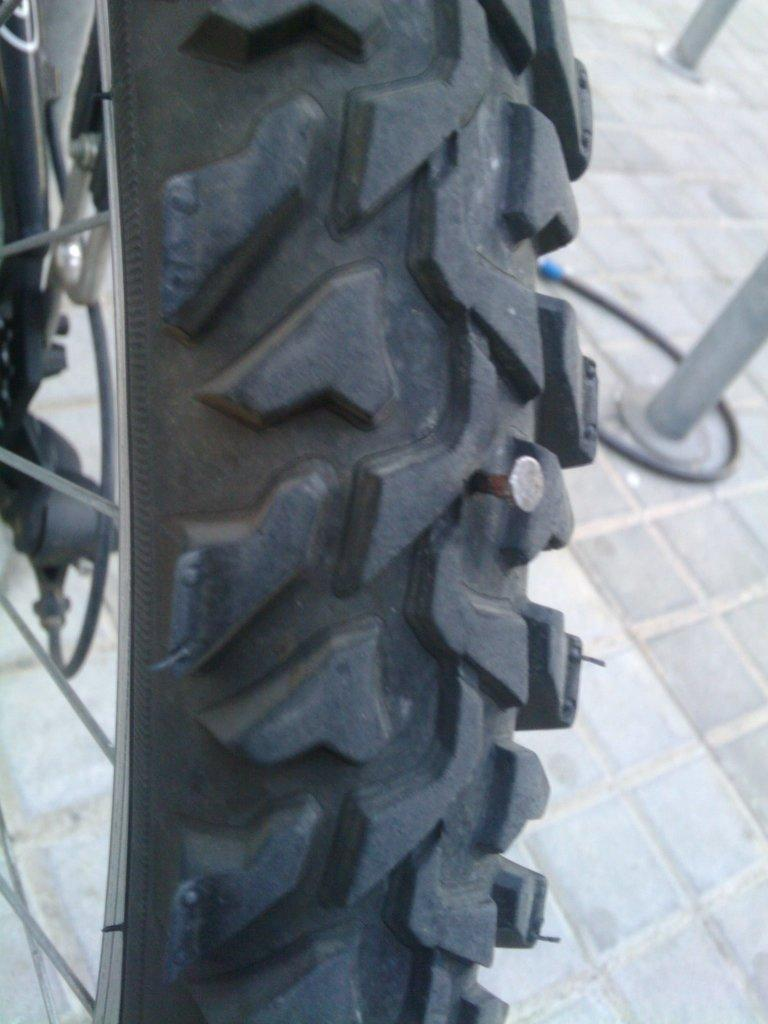What is the issue with the bicycle in the foreground? There is a nail in the Tyre of the bicycle in the foreground. What can be seen in the background of the image? There is a pipe in the background. What objects are on the floor in the background? There are two poles on the floor in the background. What type of appliance is hanging from the pipe in the background? There is no appliance present in the image; the pipe is the only object mentioned in the background. 